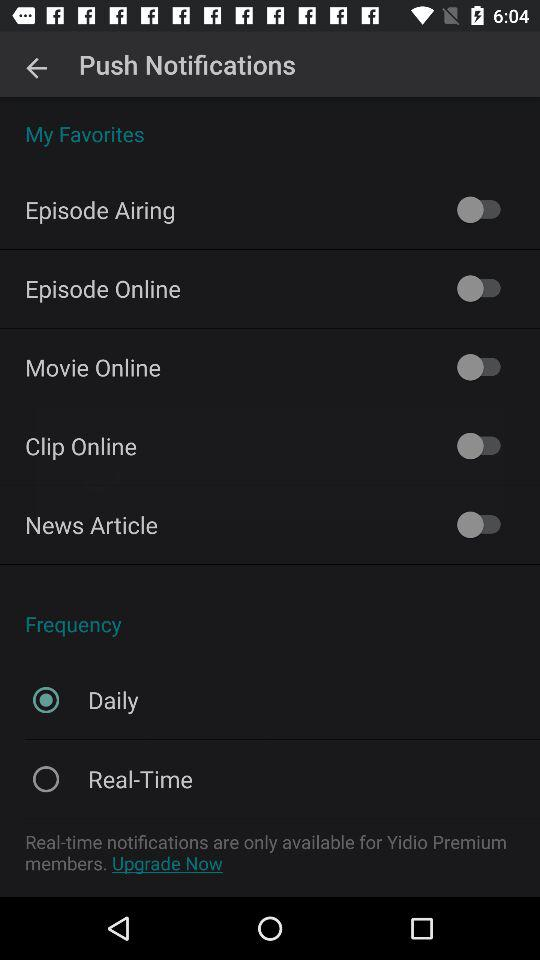How many options are there for frequency?
Answer the question using a single word or phrase. 2 